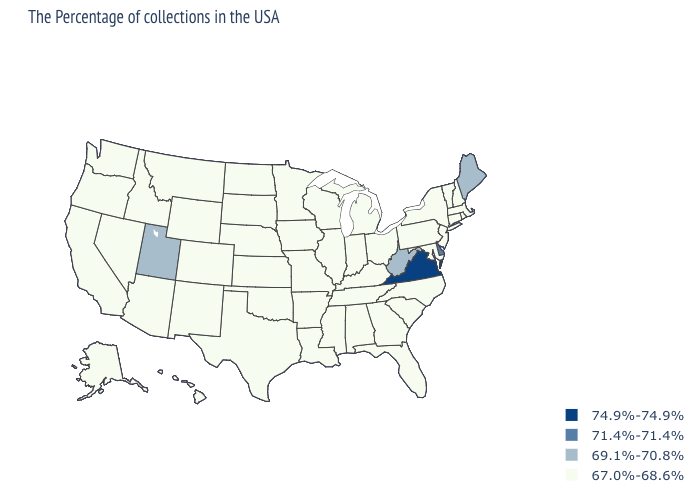Does Utah have the lowest value in the West?
Write a very short answer. No. Among the states that border Connecticut , which have the lowest value?
Quick response, please. Massachusetts, Rhode Island, New York. Name the states that have a value in the range 71.4%-71.4%?
Keep it brief. Delaware. What is the value of Wisconsin?
Concise answer only. 67.0%-68.6%. What is the lowest value in the Northeast?
Answer briefly. 67.0%-68.6%. Which states have the highest value in the USA?
Quick response, please. Virginia. Name the states that have a value in the range 67.0%-68.6%?
Be succinct. Massachusetts, Rhode Island, New Hampshire, Vermont, Connecticut, New York, New Jersey, Maryland, Pennsylvania, North Carolina, South Carolina, Ohio, Florida, Georgia, Michigan, Kentucky, Indiana, Alabama, Tennessee, Wisconsin, Illinois, Mississippi, Louisiana, Missouri, Arkansas, Minnesota, Iowa, Kansas, Nebraska, Oklahoma, Texas, South Dakota, North Dakota, Wyoming, Colorado, New Mexico, Montana, Arizona, Idaho, Nevada, California, Washington, Oregon, Alaska, Hawaii. Does Montana have the lowest value in the USA?
Be succinct. Yes. Which states have the lowest value in the West?
Concise answer only. Wyoming, Colorado, New Mexico, Montana, Arizona, Idaho, Nevada, California, Washington, Oregon, Alaska, Hawaii. Name the states that have a value in the range 74.9%-74.9%?
Keep it brief. Virginia. What is the value of New Mexico?
Keep it brief. 67.0%-68.6%. Name the states that have a value in the range 74.9%-74.9%?
Write a very short answer. Virginia. Which states hav the highest value in the West?
Write a very short answer. Utah. How many symbols are there in the legend?
Short answer required. 4. Is the legend a continuous bar?
Be succinct. No. 